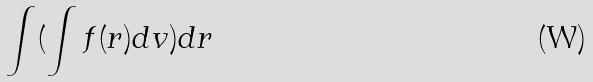Convert formula to latex. <formula><loc_0><loc_0><loc_500><loc_500>\int ( \int f ( r ) d v ) d r</formula> 